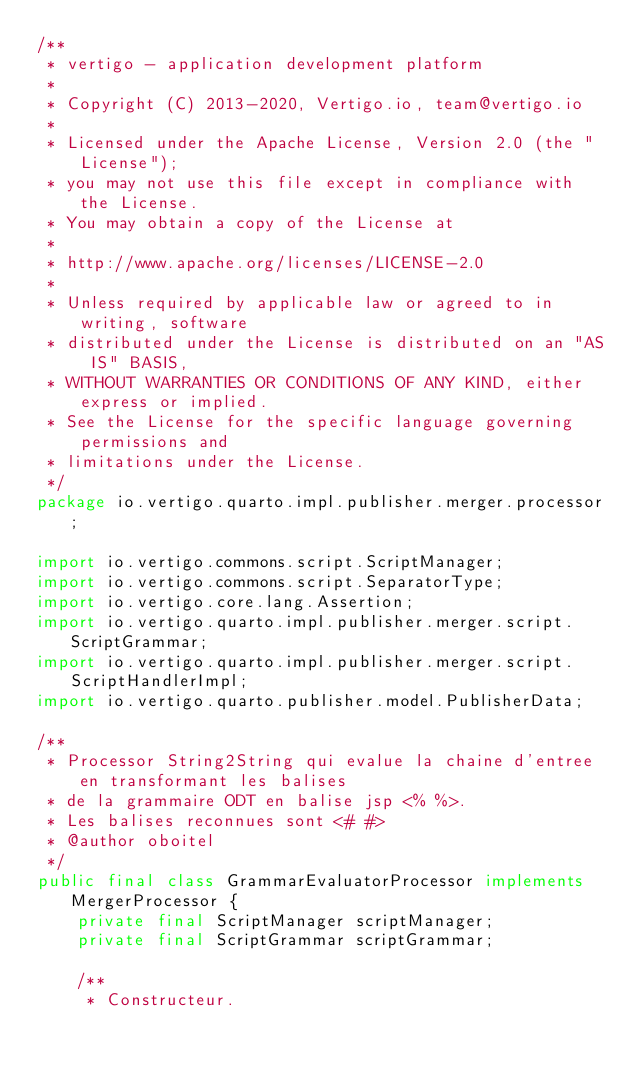Convert code to text. <code><loc_0><loc_0><loc_500><loc_500><_Java_>/**
 * vertigo - application development platform
 *
 * Copyright (C) 2013-2020, Vertigo.io, team@vertigo.io
 *
 * Licensed under the Apache License, Version 2.0 (the "License");
 * you may not use this file except in compliance with the License.
 * You may obtain a copy of the License at
 *
 * http://www.apache.org/licenses/LICENSE-2.0
 *
 * Unless required by applicable law or agreed to in writing, software
 * distributed under the License is distributed on an "AS IS" BASIS,
 * WITHOUT WARRANTIES OR CONDITIONS OF ANY KIND, either express or implied.
 * See the License for the specific language governing permissions and
 * limitations under the License.
 */
package io.vertigo.quarto.impl.publisher.merger.processor;

import io.vertigo.commons.script.ScriptManager;
import io.vertigo.commons.script.SeparatorType;
import io.vertigo.core.lang.Assertion;
import io.vertigo.quarto.impl.publisher.merger.script.ScriptGrammar;
import io.vertigo.quarto.impl.publisher.merger.script.ScriptHandlerImpl;
import io.vertigo.quarto.publisher.model.PublisherData;

/**
 * Processor String2String qui evalue la chaine d'entree en transformant les balises
 * de la grammaire ODT en balise jsp <% %>.
 * Les balises reconnues sont <# #>
 * @author oboitel
 */
public final class GrammarEvaluatorProcessor implements MergerProcessor {
	private final ScriptManager scriptManager;
	private final ScriptGrammar scriptGrammar;

	/**
	 * Constructeur.</code> 